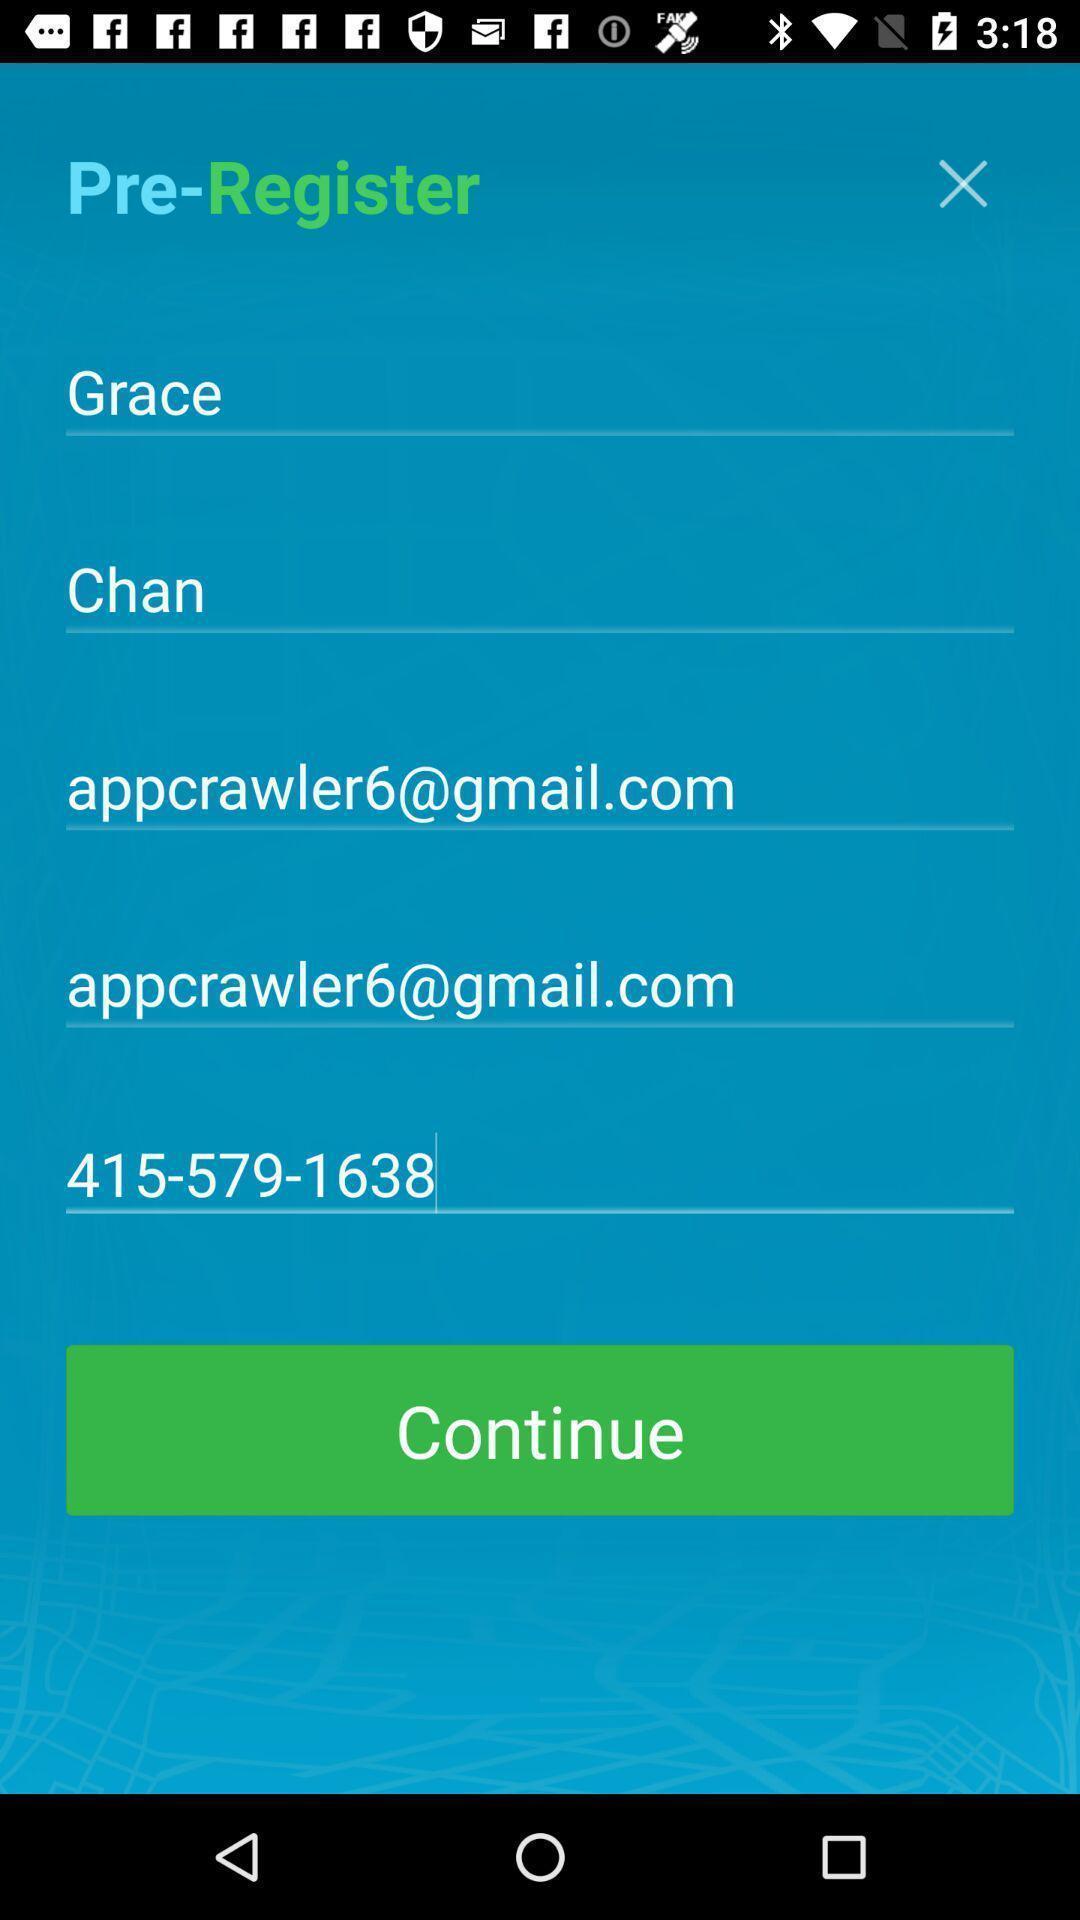What is the overall content of this screenshot? Registration page for the account with entry details. 